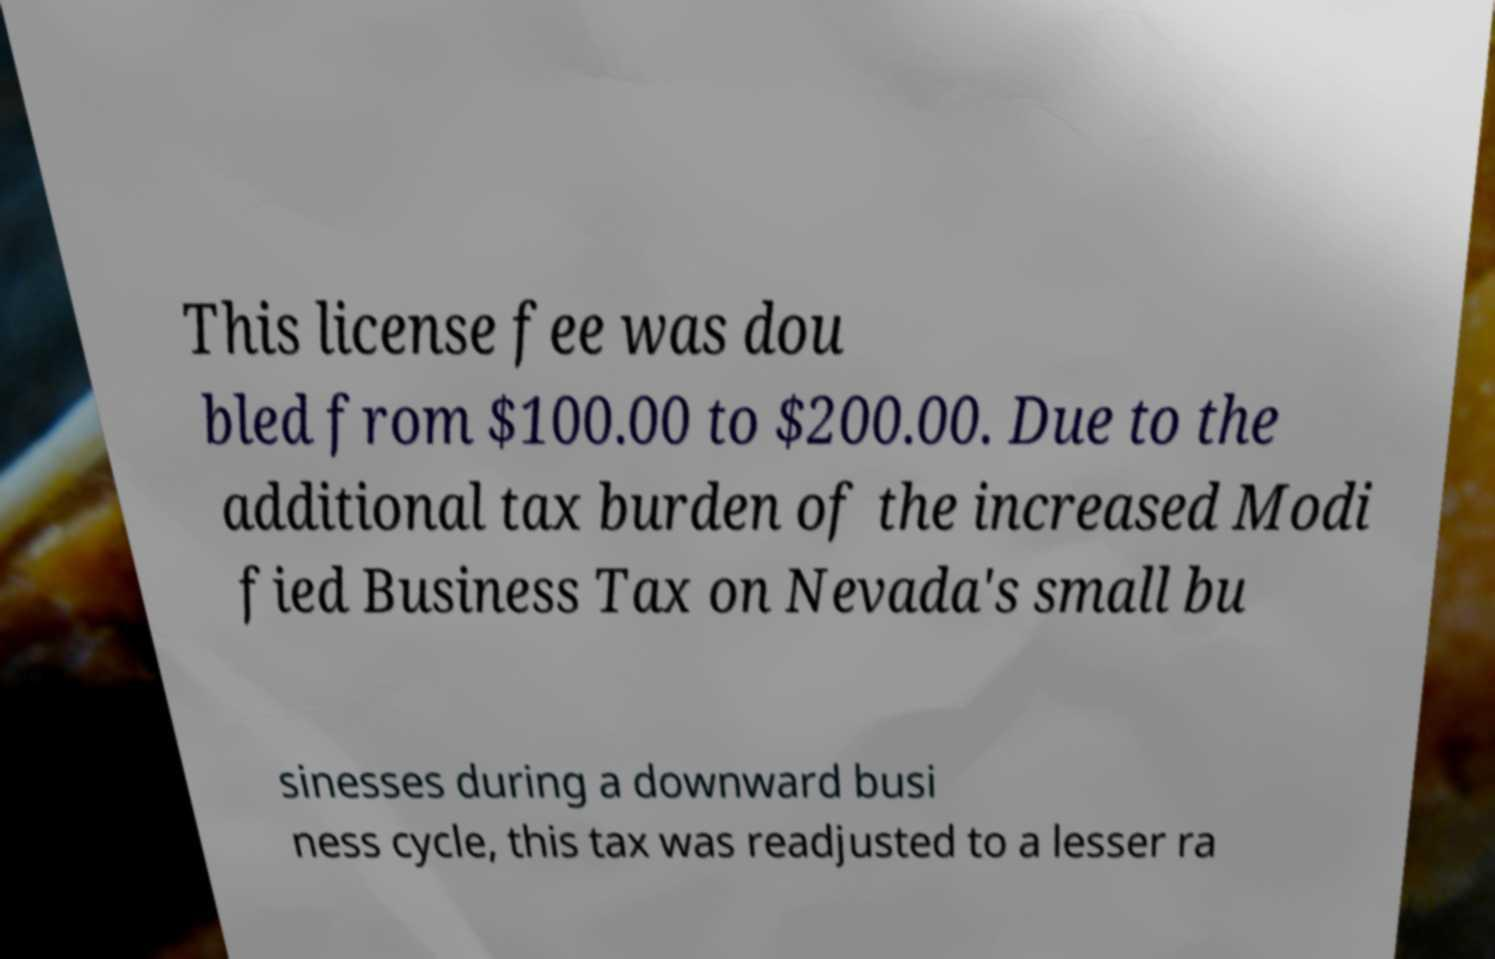I need the written content from this picture converted into text. Can you do that? This license fee was dou bled from $100.00 to $200.00. Due to the additional tax burden of the increased Modi fied Business Tax on Nevada's small bu sinesses during a downward busi ness cycle, this tax was readjusted to a lesser ra 